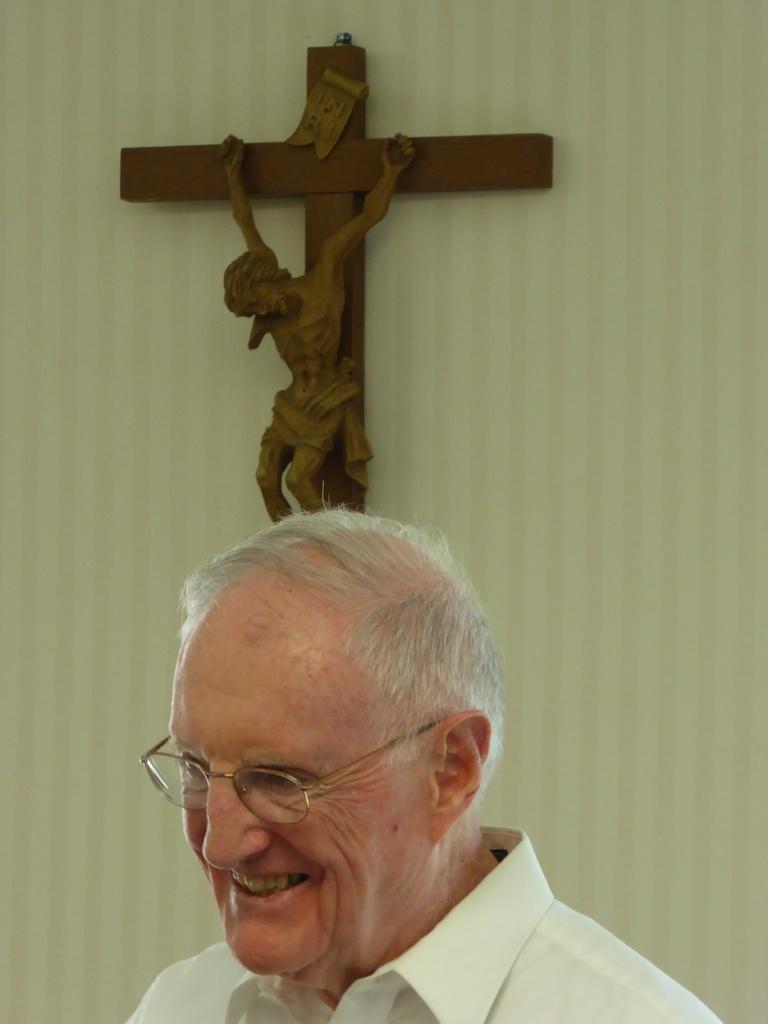In one or two sentences, can you explain what this image depicts? In this picture we can see a man wore spectacles, smiling and in the background we can see a cross on the wall. 